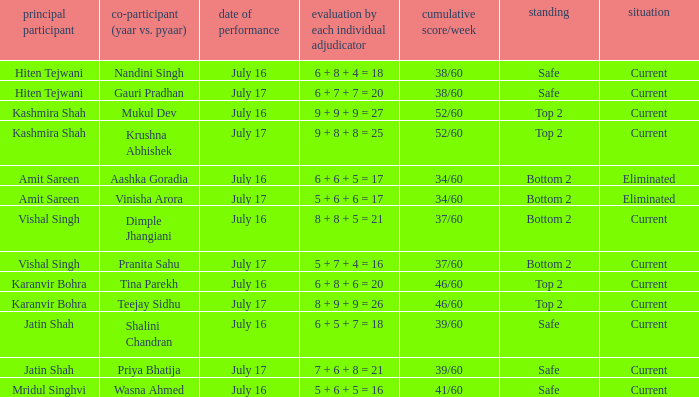What position did Pranita Sahu's team get? Bottom 2. Can you give me this table as a dict? {'header': ['principal participant', 'co-participant (yaar vs. pyaar)', 'date of performance', 'evaluation by each individual adjudicator', 'cumulative score/week', 'standing', 'situation'], 'rows': [['Hiten Tejwani', 'Nandini Singh', 'July 16', '6 + 8 + 4 = 18', '38/60', 'Safe', 'Current'], ['Hiten Tejwani', 'Gauri Pradhan', 'July 17', '6 + 7 + 7 = 20', '38/60', 'Safe', 'Current'], ['Kashmira Shah', 'Mukul Dev', 'July 16', '9 + 9 + 9 = 27', '52/60', 'Top 2', 'Current'], ['Kashmira Shah', 'Krushna Abhishek', 'July 17', '9 + 8 + 8 = 25', '52/60', 'Top 2', 'Current'], ['Amit Sareen', 'Aashka Goradia', 'July 16', '6 + 6 + 5 = 17', '34/60', 'Bottom 2', 'Eliminated'], ['Amit Sareen', 'Vinisha Arora', 'July 17', '5 + 6 + 6 = 17', '34/60', 'Bottom 2', 'Eliminated'], ['Vishal Singh', 'Dimple Jhangiani', 'July 16', '8 + 8 + 5 = 21', '37/60', 'Bottom 2', 'Current'], ['Vishal Singh', 'Pranita Sahu', 'July 17', '5 + 7 + 4 = 16', '37/60', 'Bottom 2', 'Current'], ['Karanvir Bohra', 'Tina Parekh', 'July 16', '6 + 8 + 6 = 20', '46/60', 'Top 2', 'Current'], ['Karanvir Bohra', 'Teejay Sidhu', 'July 17', '8 + 9 + 9 = 26', '46/60', 'Top 2', 'Current'], ['Jatin Shah', 'Shalini Chandran', 'July 16', '6 + 5 + 7 = 18', '39/60', 'Safe', 'Current'], ['Jatin Shah', 'Priya Bhatija', 'July 17', '7 + 6 + 8 = 21', '39/60', 'Safe', 'Current'], ['Mridul Singhvi', 'Wasna Ahmed', 'July 16', '5 + 6 + 5 = 16', '41/60', 'Safe', 'Current']]} 